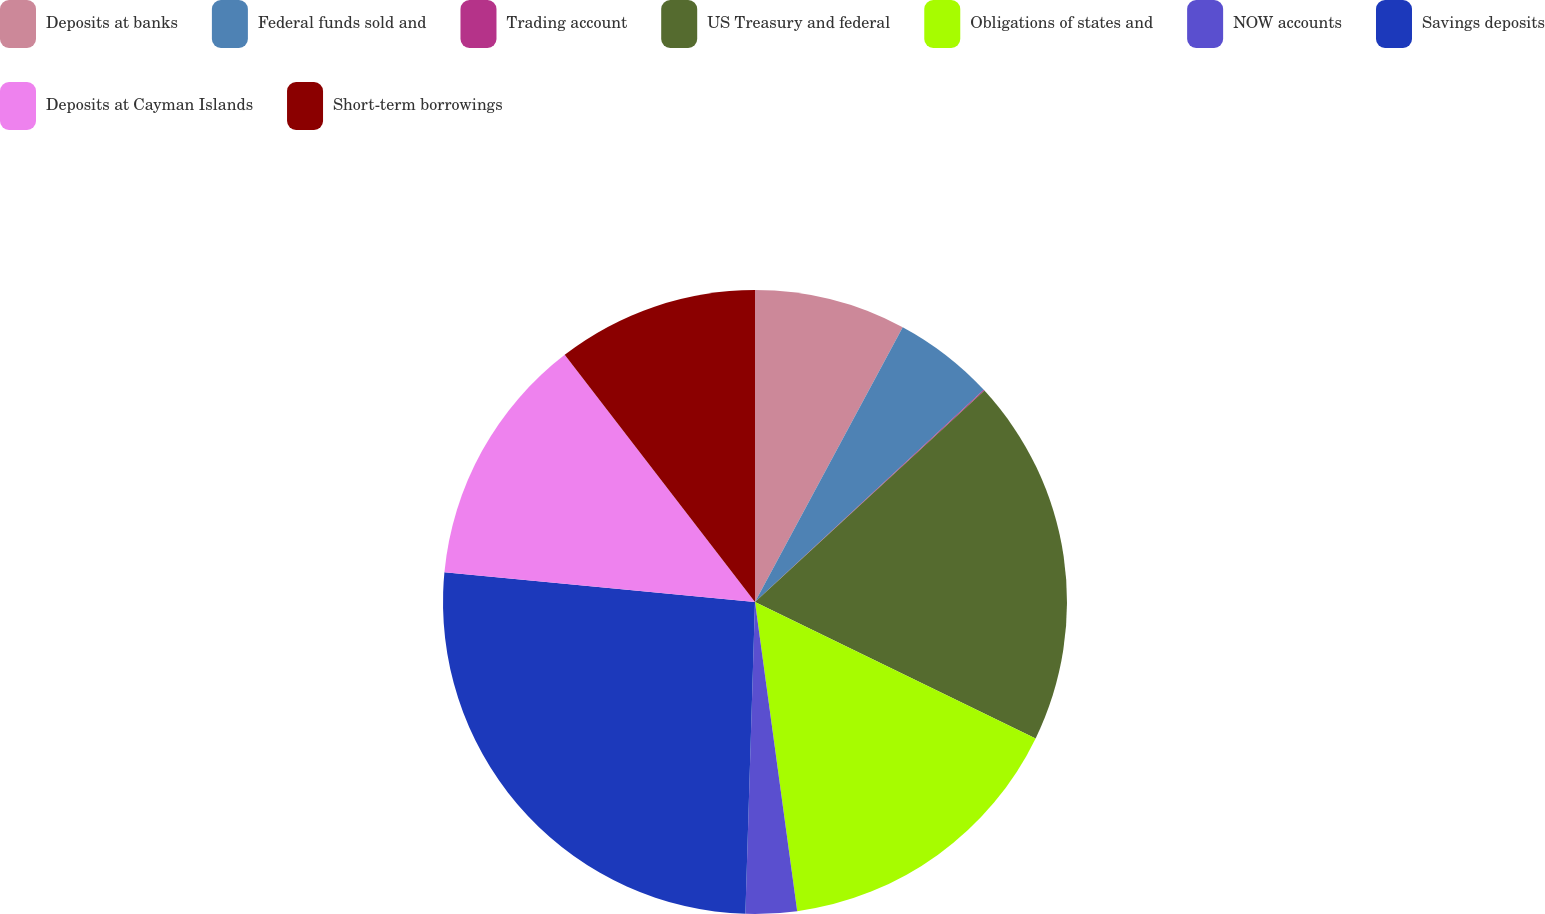<chart> <loc_0><loc_0><loc_500><loc_500><pie_chart><fcel>Deposits at banks<fcel>Federal funds sold and<fcel>Trading account<fcel>US Treasury and federal<fcel>Obligations of states and<fcel>NOW accounts<fcel>Savings deposits<fcel>Deposits at Cayman Islands<fcel>Short-term borrowings<nl><fcel>7.85%<fcel>5.25%<fcel>0.05%<fcel>19.05%<fcel>15.64%<fcel>2.65%<fcel>26.03%<fcel>13.04%<fcel>10.44%<nl></chart> 